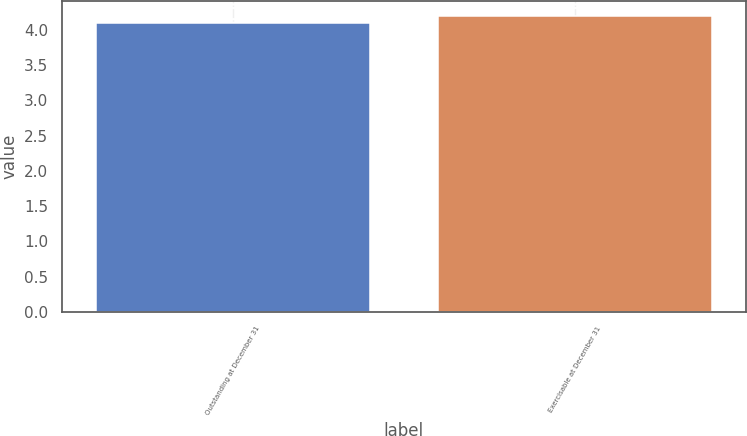Convert chart. <chart><loc_0><loc_0><loc_500><loc_500><bar_chart><fcel>Outstanding at December 31<fcel>Exercisable at December 31<nl><fcel>4.1<fcel>4.2<nl></chart> 